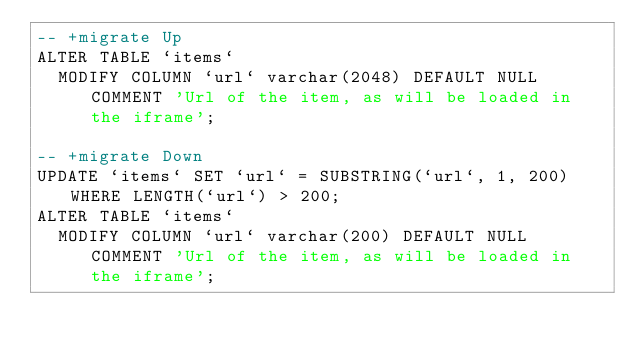Convert code to text. <code><loc_0><loc_0><loc_500><loc_500><_SQL_>-- +migrate Up
ALTER TABLE `items`
  MODIFY COLUMN `url` varchar(2048) DEFAULT NULL COMMENT 'Url of the item, as will be loaded in the iframe';

-- +migrate Down
UPDATE `items` SET `url` = SUBSTRING(`url`, 1, 200) WHERE LENGTH(`url`) > 200;
ALTER TABLE `items`
  MODIFY COLUMN `url` varchar(200) DEFAULT NULL COMMENT 'Url of the item, as will be loaded in the iframe';
</code> 